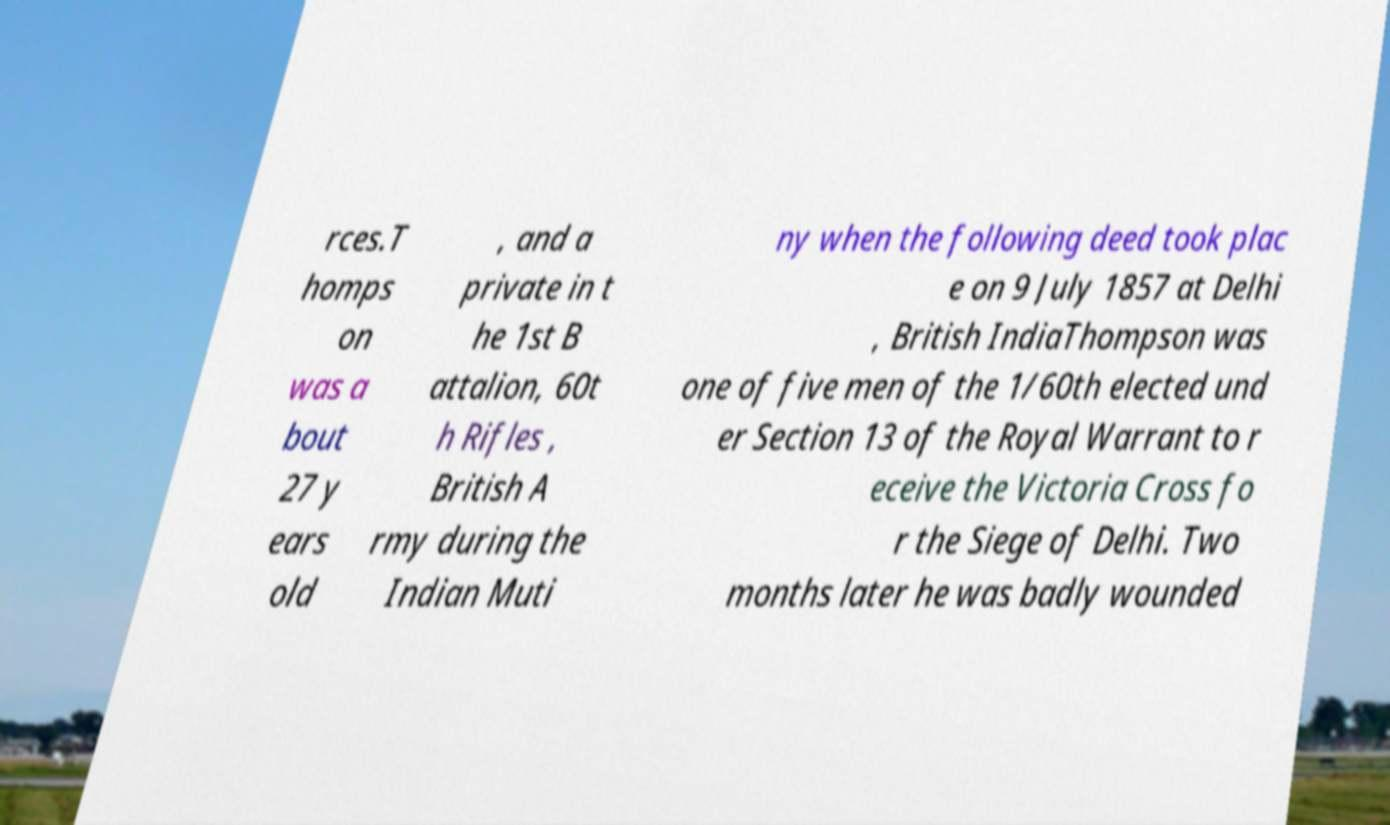There's text embedded in this image that I need extracted. Can you transcribe it verbatim? rces.T homps on was a bout 27 y ears old , and a private in t he 1st B attalion, 60t h Rifles , British A rmy during the Indian Muti ny when the following deed took plac e on 9 July 1857 at Delhi , British IndiaThompson was one of five men of the 1/60th elected und er Section 13 of the Royal Warrant to r eceive the Victoria Cross fo r the Siege of Delhi. Two months later he was badly wounded 